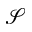Convert formula to latex. <formula><loc_0><loc_0><loc_500><loc_500>\mathcal { S }</formula> 